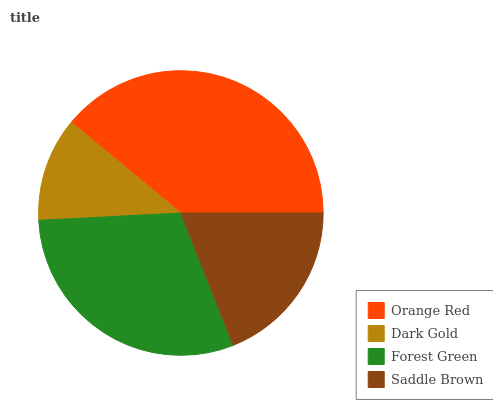Is Dark Gold the minimum?
Answer yes or no. Yes. Is Orange Red the maximum?
Answer yes or no. Yes. Is Forest Green the minimum?
Answer yes or no. No. Is Forest Green the maximum?
Answer yes or no. No. Is Forest Green greater than Dark Gold?
Answer yes or no. Yes. Is Dark Gold less than Forest Green?
Answer yes or no. Yes. Is Dark Gold greater than Forest Green?
Answer yes or no. No. Is Forest Green less than Dark Gold?
Answer yes or no. No. Is Forest Green the high median?
Answer yes or no. Yes. Is Saddle Brown the low median?
Answer yes or no. Yes. Is Dark Gold the high median?
Answer yes or no. No. Is Forest Green the low median?
Answer yes or no. No. 